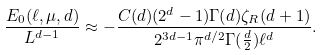<formula> <loc_0><loc_0><loc_500><loc_500>\frac { E _ { 0 } ( \ell , \mu , d ) } { L ^ { d - 1 } } \approx - \frac { C ( d ) ( 2 ^ { d } - 1 ) \Gamma ( d ) \zeta _ { R } ( d + 1 ) } { 2 ^ { 3 d - 1 } \pi ^ { d / 2 } \Gamma ( \frac { d } { 2 } ) \ell ^ { d } } .</formula> 